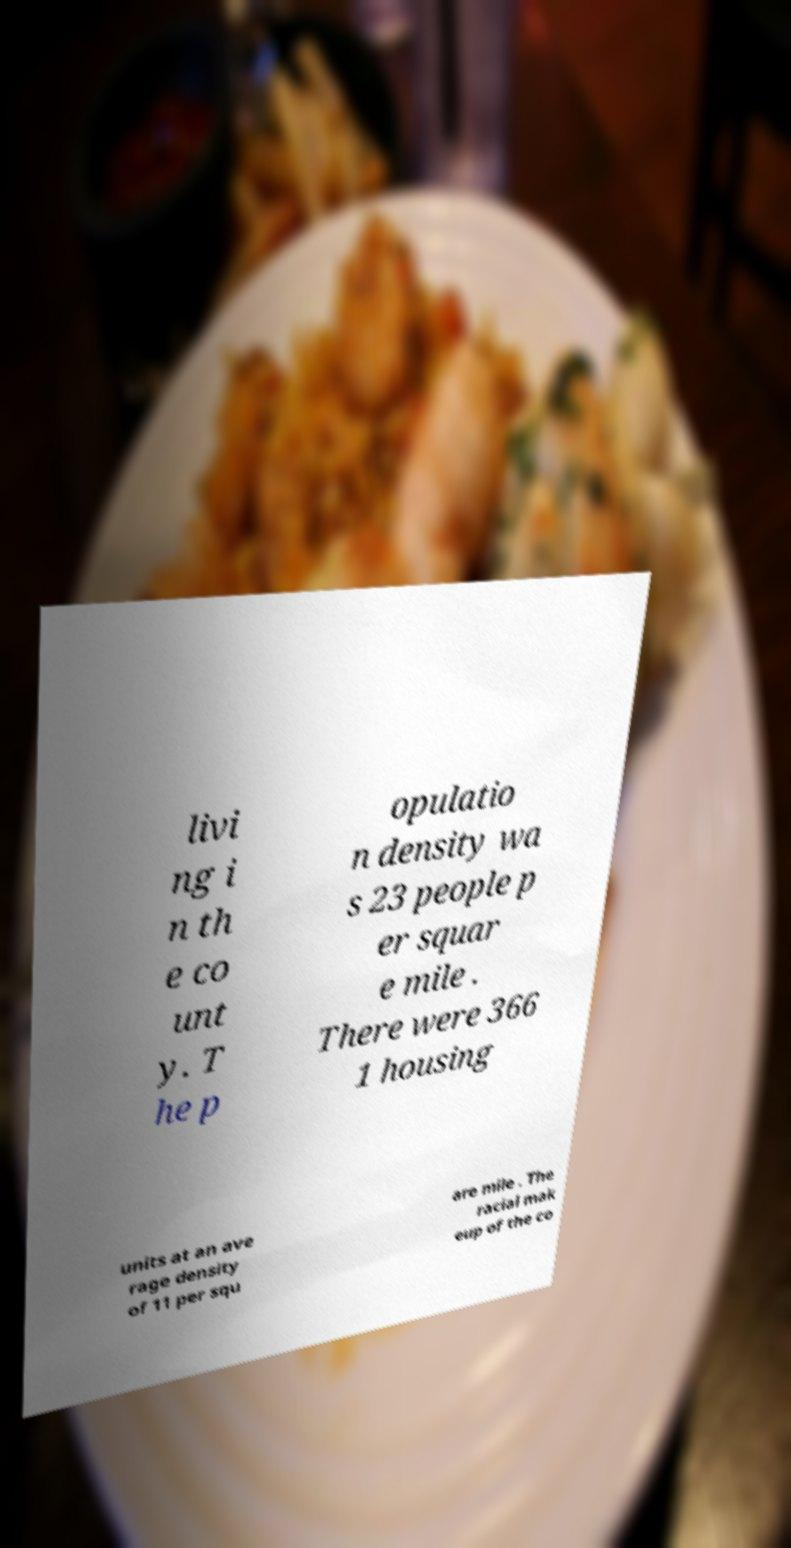I need the written content from this picture converted into text. Can you do that? livi ng i n th e co unt y. T he p opulatio n density wa s 23 people p er squar e mile . There were 366 1 housing units at an ave rage density of 11 per squ are mile . The racial mak eup of the co 